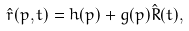Convert formula to latex. <formula><loc_0><loc_0><loc_500><loc_500>\hat { r } ( p , t ) = h ( p ) + g ( p ) \hat { R } ( t ) ,</formula> 